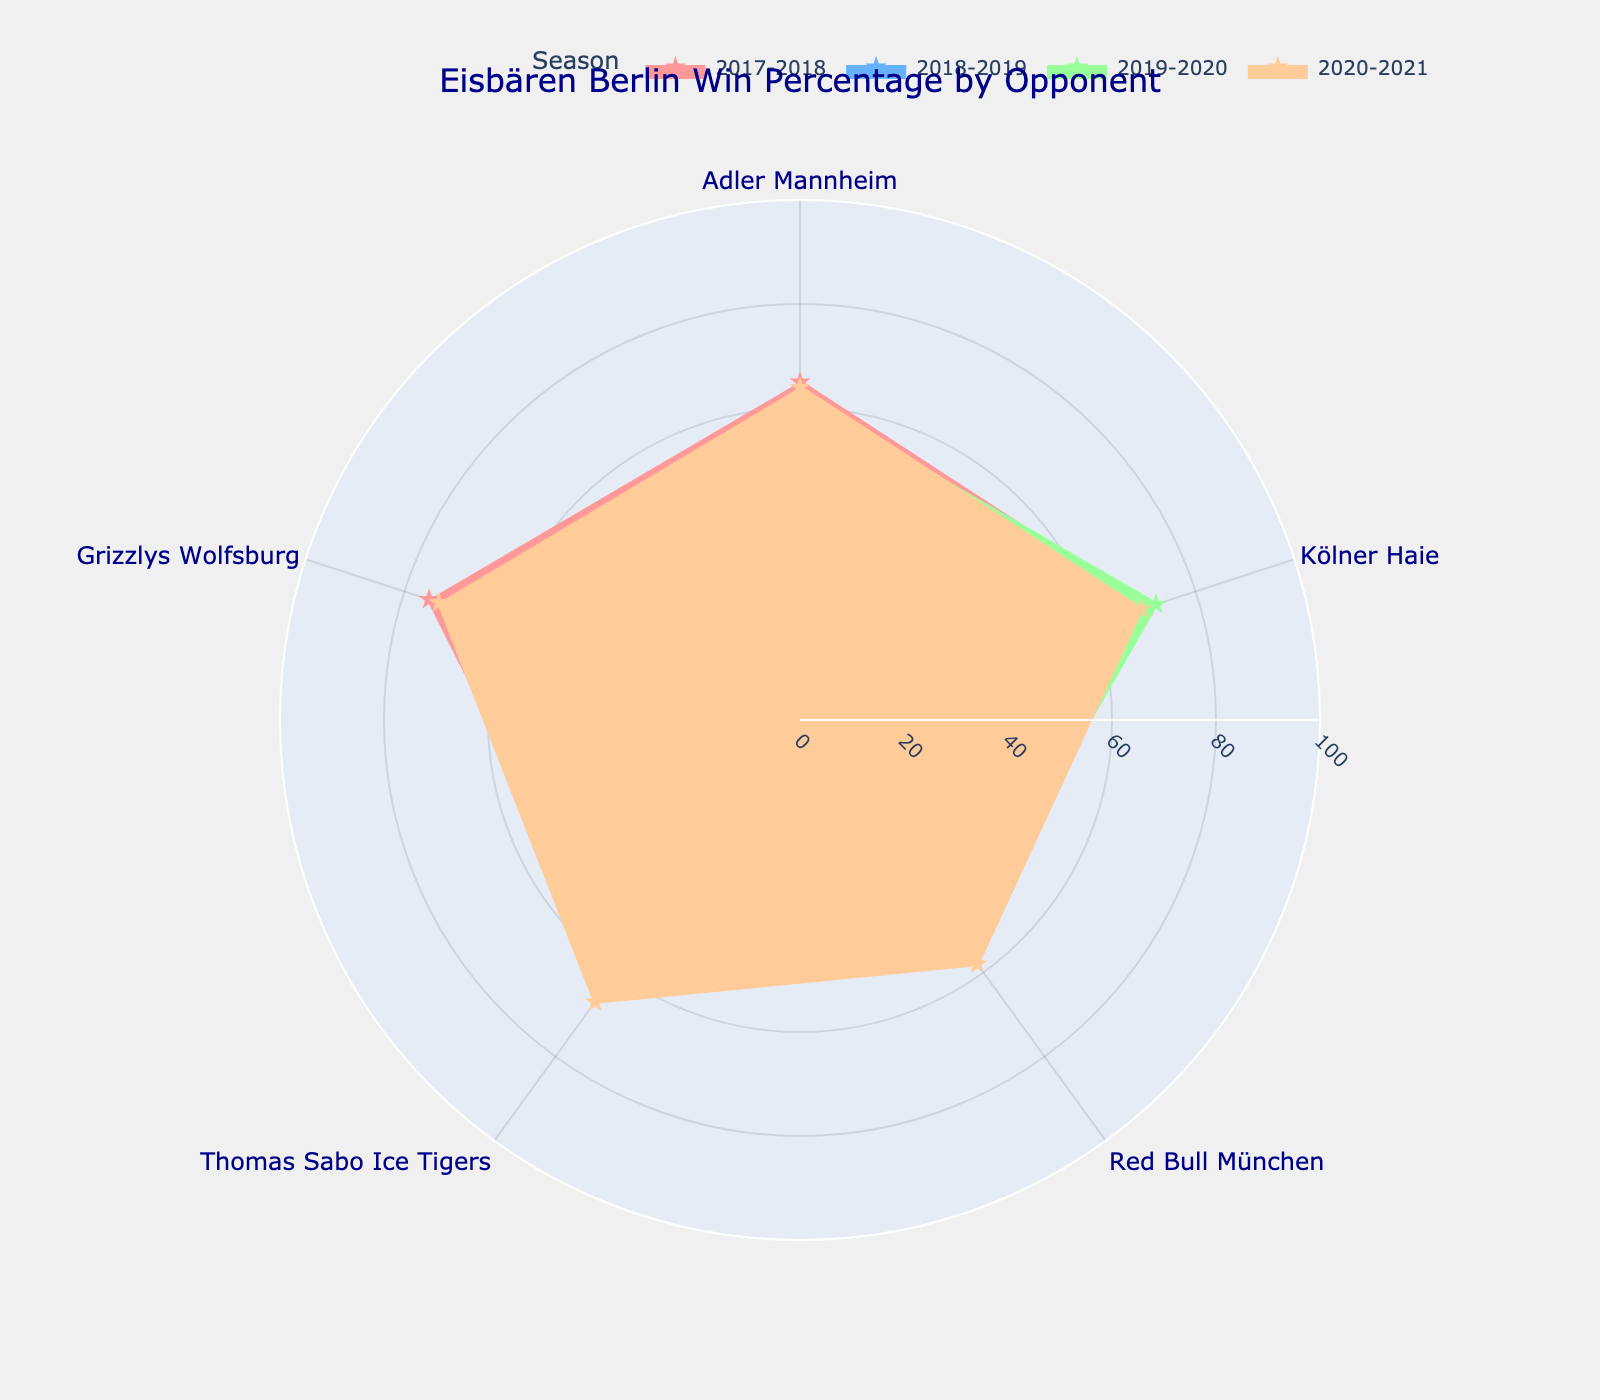Which opponent had the highest win percentage for Eisbären Berlin in the 2017-2018 season? By locating the 2017-2018 season data points on the rose chart and identifying the opponent whose data point is the farthest from the center, we see that Grizzlys Wolfsburg had the highest win percentage.
Answer: Grizzlys Wolfsburg Which season had the lowest win percentage against Red Bull München? By comparing the positions (radial distance) of the data points for Red Bull München across all seasons, the data point closest to the center corresponds to the 2018-2019 season.
Answer: 2018-2019 What is the average win percentage against Kölner Haie over all seasons? First, locate the data points for Kölner Haie across all seasons: 70.0, 68.0, 72.0, and 69.0. Then, compute the average: (70.0 + 68.0 + 72.0 + 69.0) / 4 = 69.75.
Answer: 69.75 Which season shows the most consistent win percentage across all opponents? By observing the uniformity of the radial distances from the center for each season's data points, the 2019-2020 season shows the most consistent win percentages (data points are more evenly spaced).
Answer: 2019-2020 Compare Eisbären Berlin's win percentage against Adler Mannheim in the 2017-2018 and 2020-2021 seasons. Which season had a higher percentage? Identify the data points for Adler Mannheim in the 2017-2018 and 2020-2021 seasons. The radial distance for 2020-2021 (64.0) is higher than that for 2017-2018 (65.0).
Answer: 2017-2018 Which opponent had the least variability in win percentages over the seasons? Determine by checking the angular differences for each opponent’s data points across the seasons. Kölner Haie has the least variability (data points are closer in radial distance).
Answer: Kölner Haie How did the win percentage against Thomas Sabo Ice Tigers change from the 2018-2019 to the 2019-2020 season? Compare the radial distances: for 2018-2019 it was 62.0, and for 2019-2020 it was 65.0, indicating an increase.
Answer: Increased Identify the opponent against whom Eisbären Berlin's win percentage improved the most from the 2017-2018 to 2018-2019 season. By calculating the difference in win percentages for each opponent between these two seasons, the biggest increase is for Grizzlys Wolfsburg from 75.0 to 70.0 (5.0 improvement).
Answer: Grizzlys Wolfsburg 